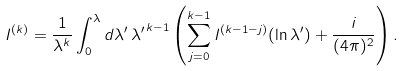Convert formula to latex. <formula><loc_0><loc_0><loc_500><loc_500>I ^ { ( k ) } = \frac { 1 } { \lambda ^ { k } } \int _ { 0 } ^ { \lambda } d \lambda ^ { \prime } \, { \lambda ^ { \prime } } ^ { k - 1 } \left ( \sum _ { j = 0 } ^ { k - 1 } I ^ { ( k - 1 - j ) } ( \ln \lambda ^ { \prime } ) + \frac { i } { ( 4 \pi ) ^ { 2 } } \right ) .</formula> 